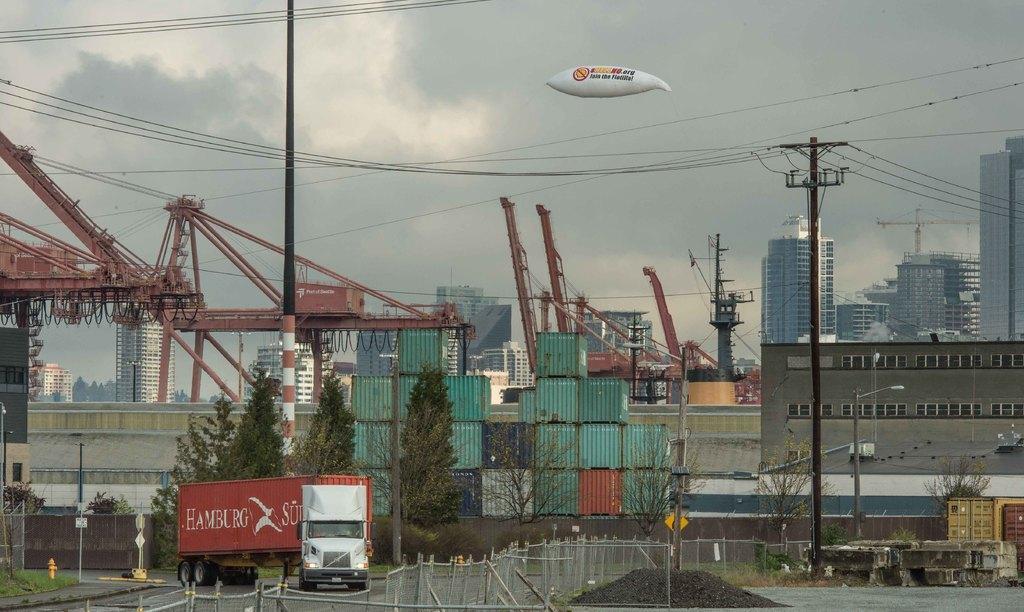In one or two sentences, can you explain what this image depicts? In this image we can see there is a crane, trees, current polls, boxes, fire hydrant, grass and sign board. At the back there are buildings, street light and fence. And at the top there is a balloon and the sky. 